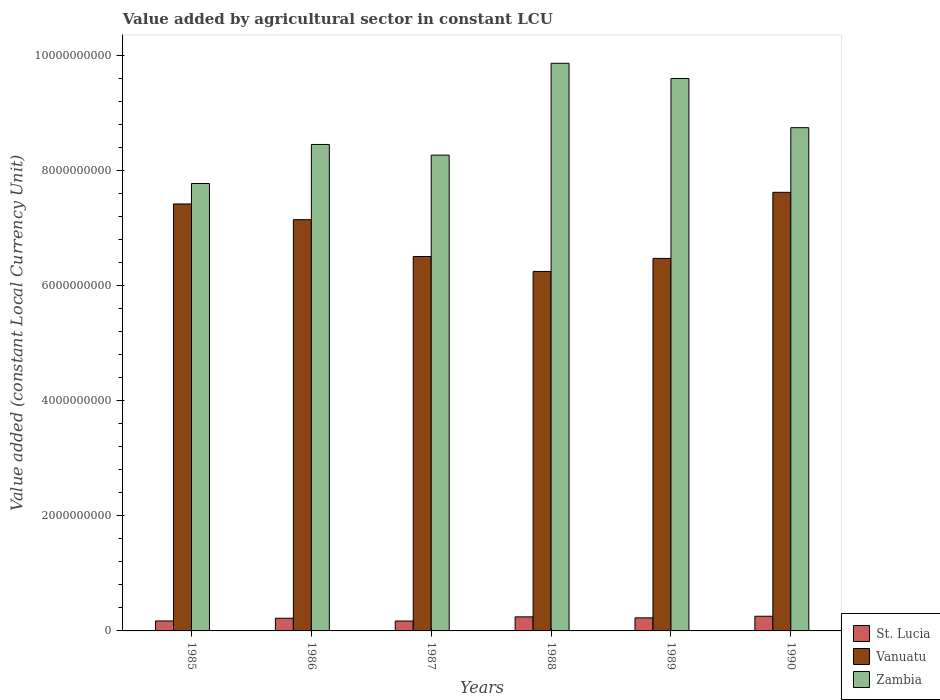How many different coloured bars are there?
Your answer should be very brief. 3. How many groups of bars are there?
Your answer should be compact. 6. Are the number of bars on each tick of the X-axis equal?
Your answer should be very brief. Yes. How many bars are there on the 4th tick from the left?
Your response must be concise. 3. How many bars are there on the 6th tick from the right?
Make the answer very short. 3. What is the label of the 5th group of bars from the left?
Give a very brief answer. 1989. What is the value added by agricultural sector in Vanuatu in 1987?
Offer a very short reply. 6.51e+09. Across all years, what is the maximum value added by agricultural sector in St. Lucia?
Offer a very short reply. 2.55e+08. Across all years, what is the minimum value added by agricultural sector in St. Lucia?
Keep it short and to the point. 1.72e+08. In which year was the value added by agricultural sector in St. Lucia minimum?
Ensure brevity in your answer.  1987. What is the total value added by agricultural sector in St. Lucia in the graph?
Your response must be concise. 1.29e+09. What is the difference between the value added by agricultural sector in Zambia in 1985 and that in 1990?
Make the answer very short. -9.70e+08. What is the difference between the value added by agricultural sector in Vanuatu in 1988 and the value added by agricultural sector in Zambia in 1987?
Your response must be concise. -2.02e+09. What is the average value added by agricultural sector in Vanuatu per year?
Your answer should be very brief. 6.90e+09. In the year 1986, what is the difference between the value added by agricultural sector in Zambia and value added by agricultural sector in Vanuatu?
Your answer should be compact. 1.31e+09. What is the ratio of the value added by agricultural sector in St. Lucia in 1986 to that in 1988?
Keep it short and to the point. 0.9. Is the difference between the value added by agricultural sector in Zambia in 1986 and 1987 greater than the difference between the value added by agricultural sector in Vanuatu in 1986 and 1987?
Provide a short and direct response. No. What is the difference between the highest and the second highest value added by agricultural sector in St. Lucia?
Offer a terse response. 1.07e+07. What is the difference between the highest and the lowest value added by agricultural sector in Zambia?
Your answer should be very brief. 2.09e+09. In how many years, is the value added by agricultural sector in Zambia greater than the average value added by agricultural sector in Zambia taken over all years?
Keep it short and to the point. 2. What does the 1st bar from the left in 1985 represents?
Provide a short and direct response. St. Lucia. What does the 1st bar from the right in 1990 represents?
Offer a very short reply. Zambia. Is it the case that in every year, the sum of the value added by agricultural sector in St. Lucia and value added by agricultural sector in Vanuatu is greater than the value added by agricultural sector in Zambia?
Offer a very short reply. No. How many bars are there?
Provide a short and direct response. 18. Are all the bars in the graph horizontal?
Offer a terse response. No. How many years are there in the graph?
Keep it short and to the point. 6. Are the values on the major ticks of Y-axis written in scientific E-notation?
Keep it short and to the point. No. Does the graph contain any zero values?
Keep it short and to the point. No. Where does the legend appear in the graph?
Your answer should be compact. Bottom right. How are the legend labels stacked?
Offer a very short reply. Vertical. What is the title of the graph?
Offer a very short reply. Value added by agricultural sector in constant LCU. Does "Macedonia" appear as one of the legend labels in the graph?
Your answer should be compact. No. What is the label or title of the X-axis?
Your answer should be very brief. Years. What is the label or title of the Y-axis?
Your response must be concise. Value added (constant Local Currency Unit). What is the Value added (constant Local Currency Unit) of St. Lucia in 1985?
Offer a very short reply. 1.73e+08. What is the Value added (constant Local Currency Unit) of Vanuatu in 1985?
Offer a very short reply. 7.42e+09. What is the Value added (constant Local Currency Unit) of Zambia in 1985?
Your response must be concise. 7.78e+09. What is the Value added (constant Local Currency Unit) of St. Lucia in 1986?
Your answer should be compact. 2.20e+08. What is the Value added (constant Local Currency Unit) in Vanuatu in 1986?
Provide a short and direct response. 7.15e+09. What is the Value added (constant Local Currency Unit) in Zambia in 1986?
Your response must be concise. 8.45e+09. What is the Value added (constant Local Currency Unit) of St. Lucia in 1987?
Offer a terse response. 1.72e+08. What is the Value added (constant Local Currency Unit) in Vanuatu in 1987?
Make the answer very short. 6.51e+09. What is the Value added (constant Local Currency Unit) of Zambia in 1987?
Your answer should be compact. 8.27e+09. What is the Value added (constant Local Currency Unit) of St. Lucia in 1988?
Your answer should be compact. 2.44e+08. What is the Value added (constant Local Currency Unit) of Vanuatu in 1988?
Make the answer very short. 6.25e+09. What is the Value added (constant Local Currency Unit) in Zambia in 1988?
Your answer should be compact. 9.87e+09. What is the Value added (constant Local Currency Unit) of St. Lucia in 1989?
Provide a short and direct response. 2.27e+08. What is the Value added (constant Local Currency Unit) of Vanuatu in 1989?
Offer a terse response. 6.47e+09. What is the Value added (constant Local Currency Unit) of Zambia in 1989?
Ensure brevity in your answer.  9.60e+09. What is the Value added (constant Local Currency Unit) in St. Lucia in 1990?
Your answer should be very brief. 2.55e+08. What is the Value added (constant Local Currency Unit) in Vanuatu in 1990?
Offer a terse response. 7.62e+09. What is the Value added (constant Local Currency Unit) of Zambia in 1990?
Offer a very short reply. 8.75e+09. Across all years, what is the maximum Value added (constant Local Currency Unit) in St. Lucia?
Your answer should be very brief. 2.55e+08. Across all years, what is the maximum Value added (constant Local Currency Unit) in Vanuatu?
Ensure brevity in your answer.  7.62e+09. Across all years, what is the maximum Value added (constant Local Currency Unit) in Zambia?
Ensure brevity in your answer.  9.87e+09. Across all years, what is the minimum Value added (constant Local Currency Unit) in St. Lucia?
Provide a succinct answer. 1.72e+08. Across all years, what is the minimum Value added (constant Local Currency Unit) of Vanuatu?
Provide a short and direct response. 6.25e+09. Across all years, what is the minimum Value added (constant Local Currency Unit) in Zambia?
Give a very brief answer. 7.78e+09. What is the total Value added (constant Local Currency Unit) of St. Lucia in the graph?
Your response must be concise. 1.29e+09. What is the total Value added (constant Local Currency Unit) in Vanuatu in the graph?
Make the answer very short. 4.14e+1. What is the total Value added (constant Local Currency Unit) of Zambia in the graph?
Ensure brevity in your answer.  5.27e+1. What is the difference between the Value added (constant Local Currency Unit) in St. Lucia in 1985 and that in 1986?
Your response must be concise. -4.69e+07. What is the difference between the Value added (constant Local Currency Unit) of Vanuatu in 1985 and that in 1986?
Provide a short and direct response. 2.73e+08. What is the difference between the Value added (constant Local Currency Unit) in Zambia in 1985 and that in 1986?
Keep it short and to the point. -6.79e+08. What is the difference between the Value added (constant Local Currency Unit) in St. Lucia in 1985 and that in 1987?
Ensure brevity in your answer.  1.33e+06. What is the difference between the Value added (constant Local Currency Unit) of Vanuatu in 1985 and that in 1987?
Your response must be concise. 9.13e+08. What is the difference between the Value added (constant Local Currency Unit) in Zambia in 1985 and that in 1987?
Offer a terse response. -4.93e+08. What is the difference between the Value added (constant Local Currency Unit) of St. Lucia in 1985 and that in 1988?
Your response must be concise. -7.10e+07. What is the difference between the Value added (constant Local Currency Unit) of Vanuatu in 1985 and that in 1988?
Give a very brief answer. 1.17e+09. What is the difference between the Value added (constant Local Currency Unit) of Zambia in 1985 and that in 1988?
Make the answer very short. -2.09e+09. What is the difference between the Value added (constant Local Currency Unit) in St. Lucia in 1985 and that in 1989?
Your answer should be very brief. -5.34e+07. What is the difference between the Value added (constant Local Currency Unit) of Vanuatu in 1985 and that in 1989?
Offer a terse response. 9.46e+08. What is the difference between the Value added (constant Local Currency Unit) of Zambia in 1985 and that in 1989?
Provide a succinct answer. -1.83e+09. What is the difference between the Value added (constant Local Currency Unit) of St. Lucia in 1985 and that in 1990?
Offer a terse response. -8.17e+07. What is the difference between the Value added (constant Local Currency Unit) in Vanuatu in 1985 and that in 1990?
Give a very brief answer. -2.02e+08. What is the difference between the Value added (constant Local Currency Unit) of Zambia in 1985 and that in 1990?
Provide a succinct answer. -9.70e+08. What is the difference between the Value added (constant Local Currency Unit) of St. Lucia in 1986 and that in 1987?
Keep it short and to the point. 4.82e+07. What is the difference between the Value added (constant Local Currency Unit) in Vanuatu in 1986 and that in 1987?
Your response must be concise. 6.40e+08. What is the difference between the Value added (constant Local Currency Unit) of Zambia in 1986 and that in 1987?
Provide a short and direct response. 1.85e+08. What is the difference between the Value added (constant Local Currency Unit) in St. Lucia in 1986 and that in 1988?
Provide a succinct answer. -2.41e+07. What is the difference between the Value added (constant Local Currency Unit) in Vanuatu in 1986 and that in 1988?
Your answer should be very brief. 9.00e+08. What is the difference between the Value added (constant Local Currency Unit) of Zambia in 1986 and that in 1988?
Your response must be concise. -1.41e+09. What is the difference between the Value added (constant Local Currency Unit) in St. Lucia in 1986 and that in 1989?
Offer a terse response. -6.55e+06. What is the difference between the Value added (constant Local Currency Unit) of Vanuatu in 1986 and that in 1989?
Provide a succinct answer. 6.73e+08. What is the difference between the Value added (constant Local Currency Unit) in Zambia in 1986 and that in 1989?
Provide a short and direct response. -1.15e+09. What is the difference between the Value added (constant Local Currency Unit) in St. Lucia in 1986 and that in 1990?
Give a very brief answer. -3.48e+07. What is the difference between the Value added (constant Local Currency Unit) in Vanuatu in 1986 and that in 1990?
Make the answer very short. -4.76e+08. What is the difference between the Value added (constant Local Currency Unit) in Zambia in 1986 and that in 1990?
Make the answer very short. -2.92e+08. What is the difference between the Value added (constant Local Currency Unit) of St. Lucia in 1987 and that in 1988?
Your answer should be very brief. -7.23e+07. What is the difference between the Value added (constant Local Currency Unit) of Vanuatu in 1987 and that in 1988?
Keep it short and to the point. 2.60e+08. What is the difference between the Value added (constant Local Currency Unit) of Zambia in 1987 and that in 1988?
Give a very brief answer. -1.60e+09. What is the difference between the Value added (constant Local Currency Unit) in St. Lucia in 1987 and that in 1989?
Offer a terse response. -5.48e+07. What is the difference between the Value added (constant Local Currency Unit) in Vanuatu in 1987 and that in 1989?
Provide a short and direct response. 3.28e+07. What is the difference between the Value added (constant Local Currency Unit) in Zambia in 1987 and that in 1989?
Your response must be concise. -1.33e+09. What is the difference between the Value added (constant Local Currency Unit) in St. Lucia in 1987 and that in 1990?
Give a very brief answer. -8.31e+07. What is the difference between the Value added (constant Local Currency Unit) in Vanuatu in 1987 and that in 1990?
Ensure brevity in your answer.  -1.12e+09. What is the difference between the Value added (constant Local Currency Unit) of Zambia in 1987 and that in 1990?
Keep it short and to the point. -4.77e+08. What is the difference between the Value added (constant Local Currency Unit) in St. Lucia in 1988 and that in 1989?
Make the answer very short. 1.75e+07. What is the difference between the Value added (constant Local Currency Unit) in Vanuatu in 1988 and that in 1989?
Your answer should be compact. -2.27e+08. What is the difference between the Value added (constant Local Currency Unit) in Zambia in 1988 and that in 1989?
Keep it short and to the point. 2.65e+08. What is the difference between the Value added (constant Local Currency Unit) of St. Lucia in 1988 and that in 1990?
Your answer should be compact. -1.07e+07. What is the difference between the Value added (constant Local Currency Unit) of Vanuatu in 1988 and that in 1990?
Provide a short and direct response. -1.38e+09. What is the difference between the Value added (constant Local Currency Unit) of Zambia in 1988 and that in 1990?
Provide a short and direct response. 1.12e+09. What is the difference between the Value added (constant Local Currency Unit) in St. Lucia in 1989 and that in 1990?
Your answer should be very brief. -2.83e+07. What is the difference between the Value added (constant Local Currency Unit) in Vanuatu in 1989 and that in 1990?
Your answer should be very brief. -1.15e+09. What is the difference between the Value added (constant Local Currency Unit) in Zambia in 1989 and that in 1990?
Ensure brevity in your answer.  8.55e+08. What is the difference between the Value added (constant Local Currency Unit) in St. Lucia in 1985 and the Value added (constant Local Currency Unit) in Vanuatu in 1986?
Keep it short and to the point. -6.97e+09. What is the difference between the Value added (constant Local Currency Unit) in St. Lucia in 1985 and the Value added (constant Local Currency Unit) in Zambia in 1986?
Make the answer very short. -8.28e+09. What is the difference between the Value added (constant Local Currency Unit) of Vanuatu in 1985 and the Value added (constant Local Currency Unit) of Zambia in 1986?
Ensure brevity in your answer.  -1.03e+09. What is the difference between the Value added (constant Local Currency Unit) in St. Lucia in 1985 and the Value added (constant Local Currency Unit) in Vanuatu in 1987?
Your response must be concise. -6.33e+09. What is the difference between the Value added (constant Local Currency Unit) of St. Lucia in 1985 and the Value added (constant Local Currency Unit) of Zambia in 1987?
Your response must be concise. -8.10e+09. What is the difference between the Value added (constant Local Currency Unit) of Vanuatu in 1985 and the Value added (constant Local Currency Unit) of Zambia in 1987?
Give a very brief answer. -8.49e+08. What is the difference between the Value added (constant Local Currency Unit) in St. Lucia in 1985 and the Value added (constant Local Currency Unit) in Vanuatu in 1988?
Offer a terse response. -6.07e+09. What is the difference between the Value added (constant Local Currency Unit) in St. Lucia in 1985 and the Value added (constant Local Currency Unit) in Zambia in 1988?
Keep it short and to the point. -9.69e+09. What is the difference between the Value added (constant Local Currency Unit) of Vanuatu in 1985 and the Value added (constant Local Currency Unit) of Zambia in 1988?
Provide a succinct answer. -2.45e+09. What is the difference between the Value added (constant Local Currency Unit) of St. Lucia in 1985 and the Value added (constant Local Currency Unit) of Vanuatu in 1989?
Offer a very short reply. -6.30e+09. What is the difference between the Value added (constant Local Currency Unit) in St. Lucia in 1985 and the Value added (constant Local Currency Unit) in Zambia in 1989?
Ensure brevity in your answer.  -9.43e+09. What is the difference between the Value added (constant Local Currency Unit) of Vanuatu in 1985 and the Value added (constant Local Currency Unit) of Zambia in 1989?
Give a very brief answer. -2.18e+09. What is the difference between the Value added (constant Local Currency Unit) in St. Lucia in 1985 and the Value added (constant Local Currency Unit) in Vanuatu in 1990?
Ensure brevity in your answer.  -7.45e+09. What is the difference between the Value added (constant Local Currency Unit) of St. Lucia in 1985 and the Value added (constant Local Currency Unit) of Zambia in 1990?
Offer a terse response. -8.57e+09. What is the difference between the Value added (constant Local Currency Unit) of Vanuatu in 1985 and the Value added (constant Local Currency Unit) of Zambia in 1990?
Give a very brief answer. -1.33e+09. What is the difference between the Value added (constant Local Currency Unit) in St. Lucia in 1986 and the Value added (constant Local Currency Unit) in Vanuatu in 1987?
Offer a very short reply. -6.29e+09. What is the difference between the Value added (constant Local Currency Unit) in St. Lucia in 1986 and the Value added (constant Local Currency Unit) in Zambia in 1987?
Ensure brevity in your answer.  -8.05e+09. What is the difference between the Value added (constant Local Currency Unit) of Vanuatu in 1986 and the Value added (constant Local Currency Unit) of Zambia in 1987?
Your answer should be very brief. -1.12e+09. What is the difference between the Value added (constant Local Currency Unit) in St. Lucia in 1986 and the Value added (constant Local Currency Unit) in Vanuatu in 1988?
Make the answer very short. -6.03e+09. What is the difference between the Value added (constant Local Currency Unit) of St. Lucia in 1986 and the Value added (constant Local Currency Unit) of Zambia in 1988?
Keep it short and to the point. -9.65e+09. What is the difference between the Value added (constant Local Currency Unit) of Vanuatu in 1986 and the Value added (constant Local Currency Unit) of Zambia in 1988?
Ensure brevity in your answer.  -2.72e+09. What is the difference between the Value added (constant Local Currency Unit) of St. Lucia in 1986 and the Value added (constant Local Currency Unit) of Vanuatu in 1989?
Provide a short and direct response. -6.25e+09. What is the difference between the Value added (constant Local Currency Unit) of St. Lucia in 1986 and the Value added (constant Local Currency Unit) of Zambia in 1989?
Provide a succinct answer. -9.38e+09. What is the difference between the Value added (constant Local Currency Unit) of Vanuatu in 1986 and the Value added (constant Local Currency Unit) of Zambia in 1989?
Make the answer very short. -2.45e+09. What is the difference between the Value added (constant Local Currency Unit) in St. Lucia in 1986 and the Value added (constant Local Currency Unit) in Vanuatu in 1990?
Offer a very short reply. -7.40e+09. What is the difference between the Value added (constant Local Currency Unit) of St. Lucia in 1986 and the Value added (constant Local Currency Unit) of Zambia in 1990?
Your response must be concise. -8.53e+09. What is the difference between the Value added (constant Local Currency Unit) of Vanuatu in 1986 and the Value added (constant Local Currency Unit) of Zambia in 1990?
Ensure brevity in your answer.  -1.60e+09. What is the difference between the Value added (constant Local Currency Unit) of St. Lucia in 1987 and the Value added (constant Local Currency Unit) of Vanuatu in 1988?
Your answer should be very brief. -6.08e+09. What is the difference between the Value added (constant Local Currency Unit) in St. Lucia in 1987 and the Value added (constant Local Currency Unit) in Zambia in 1988?
Your response must be concise. -9.69e+09. What is the difference between the Value added (constant Local Currency Unit) in Vanuatu in 1987 and the Value added (constant Local Currency Unit) in Zambia in 1988?
Your answer should be compact. -3.36e+09. What is the difference between the Value added (constant Local Currency Unit) in St. Lucia in 1987 and the Value added (constant Local Currency Unit) in Vanuatu in 1989?
Ensure brevity in your answer.  -6.30e+09. What is the difference between the Value added (constant Local Currency Unit) in St. Lucia in 1987 and the Value added (constant Local Currency Unit) in Zambia in 1989?
Provide a succinct answer. -9.43e+09. What is the difference between the Value added (constant Local Currency Unit) of Vanuatu in 1987 and the Value added (constant Local Currency Unit) of Zambia in 1989?
Give a very brief answer. -3.09e+09. What is the difference between the Value added (constant Local Currency Unit) of St. Lucia in 1987 and the Value added (constant Local Currency Unit) of Vanuatu in 1990?
Provide a succinct answer. -7.45e+09. What is the difference between the Value added (constant Local Currency Unit) of St. Lucia in 1987 and the Value added (constant Local Currency Unit) of Zambia in 1990?
Provide a short and direct response. -8.57e+09. What is the difference between the Value added (constant Local Currency Unit) of Vanuatu in 1987 and the Value added (constant Local Currency Unit) of Zambia in 1990?
Your response must be concise. -2.24e+09. What is the difference between the Value added (constant Local Currency Unit) in St. Lucia in 1988 and the Value added (constant Local Currency Unit) in Vanuatu in 1989?
Provide a succinct answer. -6.23e+09. What is the difference between the Value added (constant Local Currency Unit) of St. Lucia in 1988 and the Value added (constant Local Currency Unit) of Zambia in 1989?
Your response must be concise. -9.36e+09. What is the difference between the Value added (constant Local Currency Unit) of Vanuatu in 1988 and the Value added (constant Local Currency Unit) of Zambia in 1989?
Your answer should be compact. -3.35e+09. What is the difference between the Value added (constant Local Currency Unit) in St. Lucia in 1988 and the Value added (constant Local Currency Unit) in Vanuatu in 1990?
Make the answer very short. -7.38e+09. What is the difference between the Value added (constant Local Currency Unit) in St. Lucia in 1988 and the Value added (constant Local Currency Unit) in Zambia in 1990?
Your answer should be very brief. -8.50e+09. What is the difference between the Value added (constant Local Currency Unit) in Vanuatu in 1988 and the Value added (constant Local Currency Unit) in Zambia in 1990?
Provide a short and direct response. -2.50e+09. What is the difference between the Value added (constant Local Currency Unit) in St. Lucia in 1989 and the Value added (constant Local Currency Unit) in Vanuatu in 1990?
Your answer should be compact. -7.40e+09. What is the difference between the Value added (constant Local Currency Unit) in St. Lucia in 1989 and the Value added (constant Local Currency Unit) in Zambia in 1990?
Provide a short and direct response. -8.52e+09. What is the difference between the Value added (constant Local Currency Unit) of Vanuatu in 1989 and the Value added (constant Local Currency Unit) of Zambia in 1990?
Provide a succinct answer. -2.27e+09. What is the average Value added (constant Local Currency Unit) in St. Lucia per year?
Make the answer very short. 2.15e+08. What is the average Value added (constant Local Currency Unit) of Vanuatu per year?
Your answer should be compact. 6.90e+09. What is the average Value added (constant Local Currency Unit) in Zambia per year?
Provide a short and direct response. 8.79e+09. In the year 1985, what is the difference between the Value added (constant Local Currency Unit) of St. Lucia and Value added (constant Local Currency Unit) of Vanuatu?
Provide a succinct answer. -7.25e+09. In the year 1985, what is the difference between the Value added (constant Local Currency Unit) in St. Lucia and Value added (constant Local Currency Unit) in Zambia?
Give a very brief answer. -7.60e+09. In the year 1985, what is the difference between the Value added (constant Local Currency Unit) of Vanuatu and Value added (constant Local Currency Unit) of Zambia?
Your response must be concise. -3.56e+08. In the year 1986, what is the difference between the Value added (constant Local Currency Unit) of St. Lucia and Value added (constant Local Currency Unit) of Vanuatu?
Provide a short and direct response. -6.93e+09. In the year 1986, what is the difference between the Value added (constant Local Currency Unit) in St. Lucia and Value added (constant Local Currency Unit) in Zambia?
Offer a very short reply. -8.23e+09. In the year 1986, what is the difference between the Value added (constant Local Currency Unit) in Vanuatu and Value added (constant Local Currency Unit) in Zambia?
Keep it short and to the point. -1.31e+09. In the year 1987, what is the difference between the Value added (constant Local Currency Unit) in St. Lucia and Value added (constant Local Currency Unit) in Vanuatu?
Your answer should be very brief. -6.34e+09. In the year 1987, what is the difference between the Value added (constant Local Currency Unit) in St. Lucia and Value added (constant Local Currency Unit) in Zambia?
Keep it short and to the point. -8.10e+09. In the year 1987, what is the difference between the Value added (constant Local Currency Unit) in Vanuatu and Value added (constant Local Currency Unit) in Zambia?
Keep it short and to the point. -1.76e+09. In the year 1988, what is the difference between the Value added (constant Local Currency Unit) in St. Lucia and Value added (constant Local Currency Unit) in Vanuatu?
Provide a short and direct response. -6.00e+09. In the year 1988, what is the difference between the Value added (constant Local Currency Unit) in St. Lucia and Value added (constant Local Currency Unit) in Zambia?
Ensure brevity in your answer.  -9.62e+09. In the year 1988, what is the difference between the Value added (constant Local Currency Unit) of Vanuatu and Value added (constant Local Currency Unit) of Zambia?
Provide a short and direct response. -3.62e+09. In the year 1989, what is the difference between the Value added (constant Local Currency Unit) in St. Lucia and Value added (constant Local Currency Unit) in Vanuatu?
Ensure brevity in your answer.  -6.25e+09. In the year 1989, what is the difference between the Value added (constant Local Currency Unit) in St. Lucia and Value added (constant Local Currency Unit) in Zambia?
Your answer should be very brief. -9.37e+09. In the year 1989, what is the difference between the Value added (constant Local Currency Unit) of Vanuatu and Value added (constant Local Currency Unit) of Zambia?
Provide a short and direct response. -3.13e+09. In the year 1990, what is the difference between the Value added (constant Local Currency Unit) of St. Lucia and Value added (constant Local Currency Unit) of Vanuatu?
Your answer should be very brief. -7.37e+09. In the year 1990, what is the difference between the Value added (constant Local Currency Unit) in St. Lucia and Value added (constant Local Currency Unit) in Zambia?
Offer a very short reply. -8.49e+09. In the year 1990, what is the difference between the Value added (constant Local Currency Unit) of Vanuatu and Value added (constant Local Currency Unit) of Zambia?
Offer a very short reply. -1.12e+09. What is the ratio of the Value added (constant Local Currency Unit) of St. Lucia in 1985 to that in 1986?
Your response must be concise. 0.79. What is the ratio of the Value added (constant Local Currency Unit) in Vanuatu in 1985 to that in 1986?
Give a very brief answer. 1.04. What is the ratio of the Value added (constant Local Currency Unit) in Zambia in 1985 to that in 1986?
Give a very brief answer. 0.92. What is the ratio of the Value added (constant Local Currency Unit) of St. Lucia in 1985 to that in 1987?
Your response must be concise. 1.01. What is the ratio of the Value added (constant Local Currency Unit) of Vanuatu in 1985 to that in 1987?
Your response must be concise. 1.14. What is the ratio of the Value added (constant Local Currency Unit) in Zambia in 1985 to that in 1987?
Provide a succinct answer. 0.94. What is the ratio of the Value added (constant Local Currency Unit) of St. Lucia in 1985 to that in 1988?
Ensure brevity in your answer.  0.71. What is the ratio of the Value added (constant Local Currency Unit) in Vanuatu in 1985 to that in 1988?
Keep it short and to the point. 1.19. What is the ratio of the Value added (constant Local Currency Unit) in Zambia in 1985 to that in 1988?
Offer a terse response. 0.79. What is the ratio of the Value added (constant Local Currency Unit) in St. Lucia in 1985 to that in 1989?
Provide a short and direct response. 0.76. What is the ratio of the Value added (constant Local Currency Unit) of Vanuatu in 1985 to that in 1989?
Give a very brief answer. 1.15. What is the ratio of the Value added (constant Local Currency Unit) of Zambia in 1985 to that in 1989?
Offer a terse response. 0.81. What is the ratio of the Value added (constant Local Currency Unit) of St. Lucia in 1985 to that in 1990?
Your answer should be compact. 0.68. What is the ratio of the Value added (constant Local Currency Unit) in Vanuatu in 1985 to that in 1990?
Your answer should be very brief. 0.97. What is the ratio of the Value added (constant Local Currency Unit) of Zambia in 1985 to that in 1990?
Your answer should be compact. 0.89. What is the ratio of the Value added (constant Local Currency Unit) in St. Lucia in 1986 to that in 1987?
Make the answer very short. 1.28. What is the ratio of the Value added (constant Local Currency Unit) in Vanuatu in 1986 to that in 1987?
Your response must be concise. 1.1. What is the ratio of the Value added (constant Local Currency Unit) in Zambia in 1986 to that in 1987?
Give a very brief answer. 1.02. What is the ratio of the Value added (constant Local Currency Unit) of St. Lucia in 1986 to that in 1988?
Give a very brief answer. 0.9. What is the ratio of the Value added (constant Local Currency Unit) in Vanuatu in 1986 to that in 1988?
Make the answer very short. 1.14. What is the ratio of the Value added (constant Local Currency Unit) of Zambia in 1986 to that in 1988?
Give a very brief answer. 0.86. What is the ratio of the Value added (constant Local Currency Unit) of St. Lucia in 1986 to that in 1989?
Offer a terse response. 0.97. What is the ratio of the Value added (constant Local Currency Unit) of Vanuatu in 1986 to that in 1989?
Ensure brevity in your answer.  1.1. What is the ratio of the Value added (constant Local Currency Unit) in Zambia in 1986 to that in 1989?
Offer a very short reply. 0.88. What is the ratio of the Value added (constant Local Currency Unit) in St. Lucia in 1986 to that in 1990?
Make the answer very short. 0.86. What is the ratio of the Value added (constant Local Currency Unit) of Vanuatu in 1986 to that in 1990?
Make the answer very short. 0.94. What is the ratio of the Value added (constant Local Currency Unit) of Zambia in 1986 to that in 1990?
Provide a succinct answer. 0.97. What is the ratio of the Value added (constant Local Currency Unit) of St. Lucia in 1987 to that in 1988?
Keep it short and to the point. 0.7. What is the ratio of the Value added (constant Local Currency Unit) of Vanuatu in 1987 to that in 1988?
Keep it short and to the point. 1.04. What is the ratio of the Value added (constant Local Currency Unit) in Zambia in 1987 to that in 1988?
Make the answer very short. 0.84. What is the ratio of the Value added (constant Local Currency Unit) of St. Lucia in 1987 to that in 1989?
Keep it short and to the point. 0.76. What is the ratio of the Value added (constant Local Currency Unit) of Vanuatu in 1987 to that in 1989?
Offer a very short reply. 1.01. What is the ratio of the Value added (constant Local Currency Unit) in Zambia in 1987 to that in 1989?
Provide a short and direct response. 0.86. What is the ratio of the Value added (constant Local Currency Unit) of St. Lucia in 1987 to that in 1990?
Provide a short and direct response. 0.67. What is the ratio of the Value added (constant Local Currency Unit) of Vanuatu in 1987 to that in 1990?
Your response must be concise. 0.85. What is the ratio of the Value added (constant Local Currency Unit) of Zambia in 1987 to that in 1990?
Give a very brief answer. 0.95. What is the ratio of the Value added (constant Local Currency Unit) in St. Lucia in 1988 to that in 1989?
Your answer should be compact. 1.08. What is the ratio of the Value added (constant Local Currency Unit) in Vanuatu in 1988 to that in 1989?
Make the answer very short. 0.96. What is the ratio of the Value added (constant Local Currency Unit) in Zambia in 1988 to that in 1989?
Your answer should be very brief. 1.03. What is the ratio of the Value added (constant Local Currency Unit) of St. Lucia in 1988 to that in 1990?
Your answer should be compact. 0.96. What is the ratio of the Value added (constant Local Currency Unit) in Vanuatu in 1988 to that in 1990?
Give a very brief answer. 0.82. What is the ratio of the Value added (constant Local Currency Unit) of Zambia in 1988 to that in 1990?
Your answer should be compact. 1.13. What is the ratio of the Value added (constant Local Currency Unit) of St. Lucia in 1989 to that in 1990?
Your answer should be compact. 0.89. What is the ratio of the Value added (constant Local Currency Unit) in Vanuatu in 1989 to that in 1990?
Your response must be concise. 0.85. What is the ratio of the Value added (constant Local Currency Unit) of Zambia in 1989 to that in 1990?
Provide a succinct answer. 1.1. What is the difference between the highest and the second highest Value added (constant Local Currency Unit) in St. Lucia?
Provide a succinct answer. 1.07e+07. What is the difference between the highest and the second highest Value added (constant Local Currency Unit) of Vanuatu?
Give a very brief answer. 2.02e+08. What is the difference between the highest and the second highest Value added (constant Local Currency Unit) of Zambia?
Give a very brief answer. 2.65e+08. What is the difference between the highest and the lowest Value added (constant Local Currency Unit) of St. Lucia?
Ensure brevity in your answer.  8.31e+07. What is the difference between the highest and the lowest Value added (constant Local Currency Unit) of Vanuatu?
Offer a very short reply. 1.38e+09. What is the difference between the highest and the lowest Value added (constant Local Currency Unit) in Zambia?
Offer a terse response. 2.09e+09. 